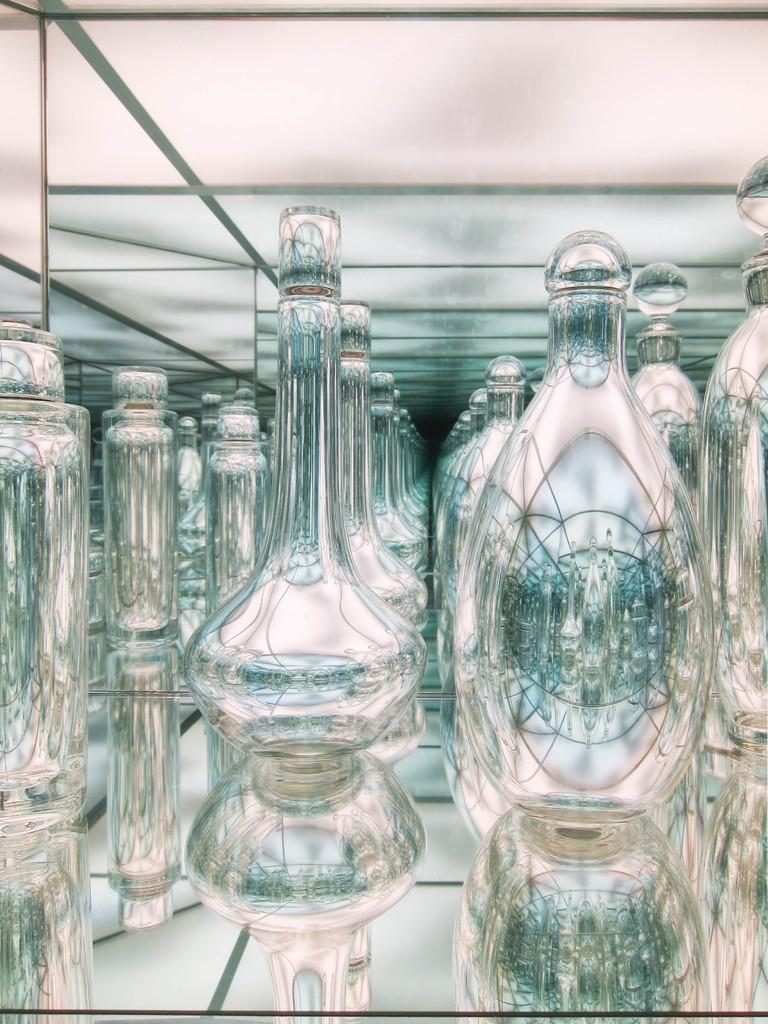What type of objects can be seen in the image? There are glass objects in the image. What type of animals can be seen at the sea in the image? There is no sea or animals present in the image; it only features glass objects. What type of balance is required to maintain the glass objects in the image? The image does not show any specific balance requirements for the glass objects, as it only provides a visual representation of them. 